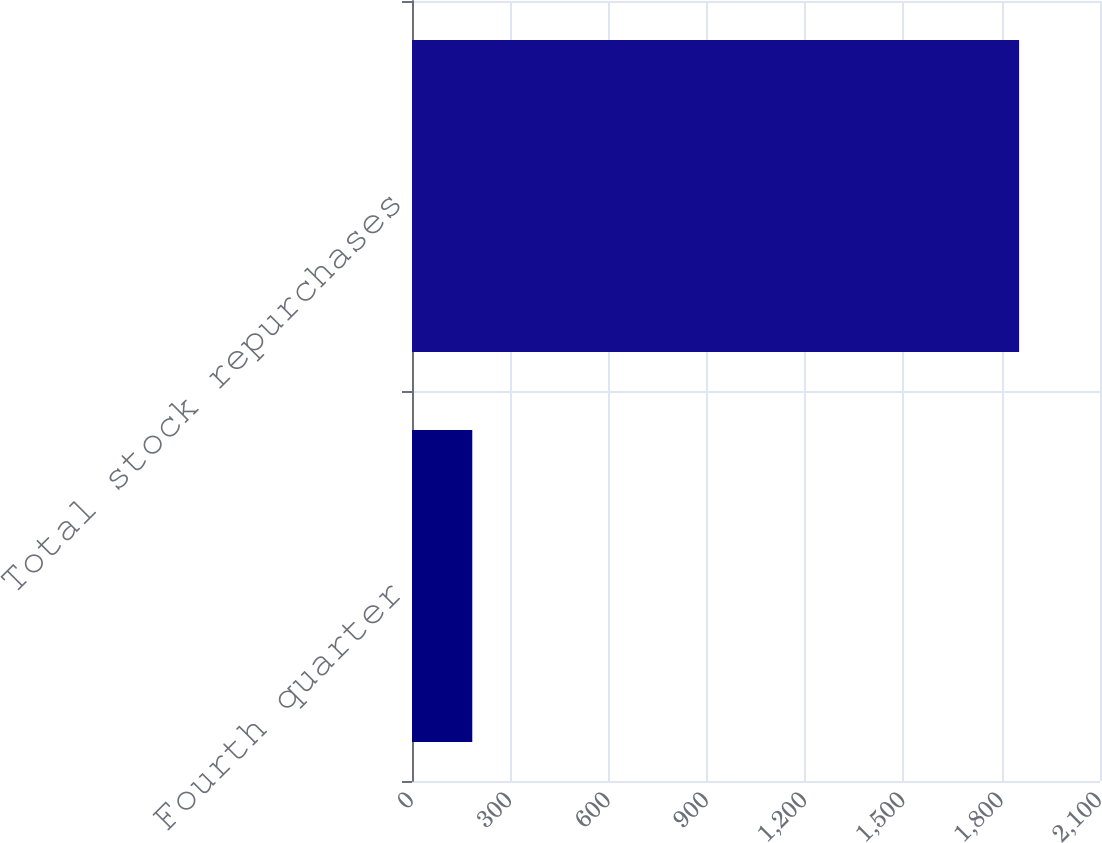Convert chart. <chart><loc_0><loc_0><loc_500><loc_500><bar_chart><fcel>Fourth quarter<fcel>Total stock repurchases<nl><fcel>184<fcel>1853<nl></chart> 